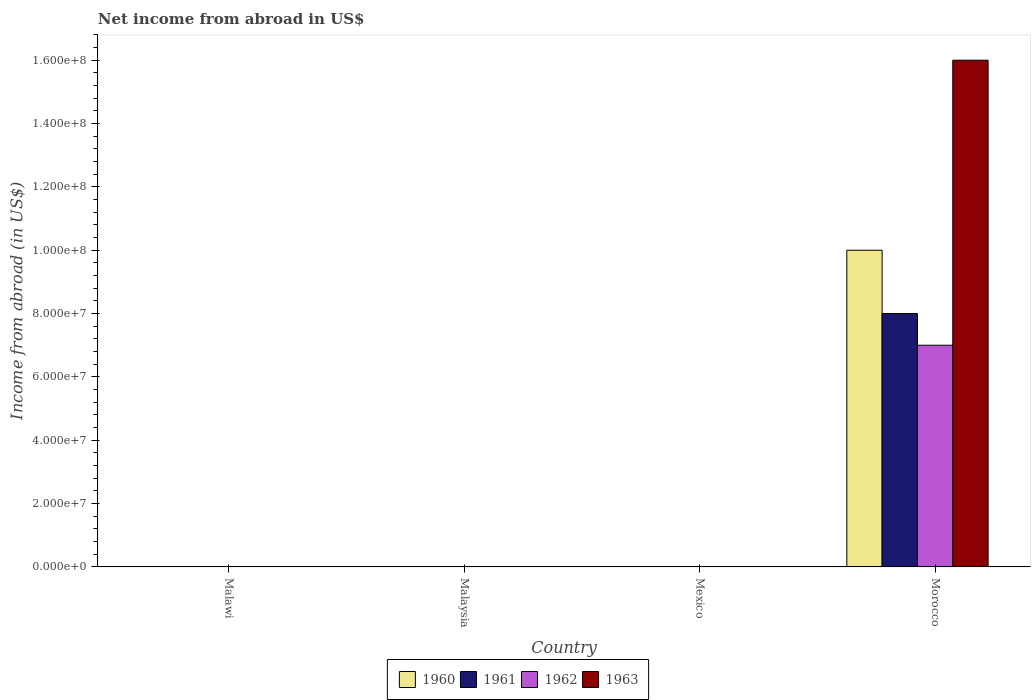How many bars are there on the 1st tick from the left?
Ensure brevity in your answer.  0. What is the label of the 1st group of bars from the left?
Your answer should be compact. Malawi. In how many cases, is the number of bars for a given country not equal to the number of legend labels?
Provide a succinct answer. 3. Across all countries, what is the maximum net income from abroad in 1962?
Provide a short and direct response. 7.00e+07. Across all countries, what is the minimum net income from abroad in 1960?
Provide a short and direct response. 0. In which country was the net income from abroad in 1963 maximum?
Provide a succinct answer. Morocco. What is the total net income from abroad in 1963 in the graph?
Offer a terse response. 1.60e+08. What is the difference between the net income from abroad in 1963 in Morocco and the net income from abroad in 1960 in Mexico?
Provide a short and direct response. 1.60e+08. What is the average net income from abroad in 1963 per country?
Ensure brevity in your answer.  4.00e+07. What is the difference between the net income from abroad of/in 1963 and net income from abroad of/in 1960 in Morocco?
Give a very brief answer. 6.00e+07. In how many countries, is the net income from abroad in 1962 greater than 120000000 US$?
Offer a terse response. 0. What is the difference between the highest and the lowest net income from abroad in 1960?
Make the answer very short. 1.00e+08. In how many countries, is the net income from abroad in 1963 greater than the average net income from abroad in 1963 taken over all countries?
Provide a succinct answer. 1. Is it the case that in every country, the sum of the net income from abroad in 1960 and net income from abroad in 1962 is greater than the sum of net income from abroad in 1963 and net income from abroad in 1961?
Provide a short and direct response. No. Is it the case that in every country, the sum of the net income from abroad in 1960 and net income from abroad in 1961 is greater than the net income from abroad in 1963?
Your answer should be compact. No. How many bars are there?
Give a very brief answer. 4. Are all the bars in the graph horizontal?
Your answer should be compact. No. How many countries are there in the graph?
Your answer should be very brief. 4. What is the difference between two consecutive major ticks on the Y-axis?
Your response must be concise. 2.00e+07. Does the graph contain any zero values?
Make the answer very short. Yes. How many legend labels are there?
Make the answer very short. 4. How are the legend labels stacked?
Ensure brevity in your answer.  Horizontal. What is the title of the graph?
Your answer should be very brief. Net income from abroad in US$. What is the label or title of the Y-axis?
Provide a succinct answer. Income from abroad (in US$). What is the Income from abroad (in US$) of 1961 in Malawi?
Make the answer very short. 0. What is the Income from abroad (in US$) of 1963 in Malawi?
Ensure brevity in your answer.  0. What is the Income from abroad (in US$) of 1962 in Malaysia?
Provide a short and direct response. 0. What is the Income from abroad (in US$) in 1963 in Malaysia?
Provide a succinct answer. 0. What is the Income from abroad (in US$) of 1960 in Mexico?
Offer a very short reply. 0. What is the Income from abroad (in US$) in 1962 in Mexico?
Give a very brief answer. 0. What is the Income from abroad (in US$) in 1963 in Mexico?
Ensure brevity in your answer.  0. What is the Income from abroad (in US$) of 1960 in Morocco?
Offer a very short reply. 1.00e+08. What is the Income from abroad (in US$) of 1961 in Morocco?
Keep it short and to the point. 8.00e+07. What is the Income from abroad (in US$) in 1962 in Morocco?
Keep it short and to the point. 7.00e+07. What is the Income from abroad (in US$) of 1963 in Morocco?
Your answer should be compact. 1.60e+08. Across all countries, what is the maximum Income from abroad (in US$) of 1960?
Provide a succinct answer. 1.00e+08. Across all countries, what is the maximum Income from abroad (in US$) in 1961?
Your answer should be compact. 8.00e+07. Across all countries, what is the maximum Income from abroad (in US$) of 1962?
Your answer should be very brief. 7.00e+07. Across all countries, what is the maximum Income from abroad (in US$) of 1963?
Provide a succinct answer. 1.60e+08. What is the total Income from abroad (in US$) in 1960 in the graph?
Provide a short and direct response. 1.00e+08. What is the total Income from abroad (in US$) of 1961 in the graph?
Provide a short and direct response. 8.00e+07. What is the total Income from abroad (in US$) in 1962 in the graph?
Offer a terse response. 7.00e+07. What is the total Income from abroad (in US$) in 1963 in the graph?
Offer a terse response. 1.60e+08. What is the average Income from abroad (in US$) in 1960 per country?
Make the answer very short. 2.50e+07. What is the average Income from abroad (in US$) in 1961 per country?
Give a very brief answer. 2.00e+07. What is the average Income from abroad (in US$) of 1962 per country?
Ensure brevity in your answer.  1.75e+07. What is the average Income from abroad (in US$) of 1963 per country?
Your response must be concise. 4.00e+07. What is the difference between the Income from abroad (in US$) of 1960 and Income from abroad (in US$) of 1961 in Morocco?
Ensure brevity in your answer.  2.00e+07. What is the difference between the Income from abroad (in US$) of 1960 and Income from abroad (in US$) of 1962 in Morocco?
Your answer should be compact. 3.00e+07. What is the difference between the Income from abroad (in US$) in 1960 and Income from abroad (in US$) in 1963 in Morocco?
Your response must be concise. -6.00e+07. What is the difference between the Income from abroad (in US$) of 1961 and Income from abroad (in US$) of 1962 in Morocco?
Offer a terse response. 1.00e+07. What is the difference between the Income from abroad (in US$) in 1961 and Income from abroad (in US$) in 1963 in Morocco?
Your response must be concise. -8.00e+07. What is the difference between the Income from abroad (in US$) in 1962 and Income from abroad (in US$) in 1963 in Morocco?
Give a very brief answer. -9.00e+07. What is the difference between the highest and the lowest Income from abroad (in US$) in 1960?
Your response must be concise. 1.00e+08. What is the difference between the highest and the lowest Income from abroad (in US$) in 1961?
Offer a terse response. 8.00e+07. What is the difference between the highest and the lowest Income from abroad (in US$) of 1962?
Offer a terse response. 7.00e+07. What is the difference between the highest and the lowest Income from abroad (in US$) of 1963?
Provide a short and direct response. 1.60e+08. 